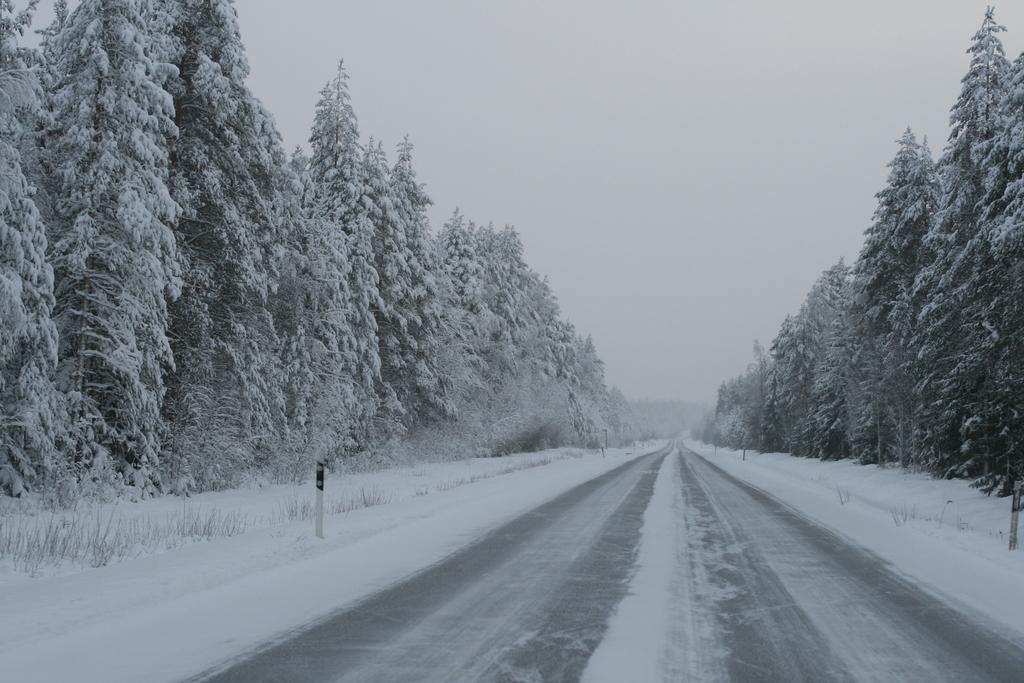What type of weather is depicted in the image? There is snow in the image, indicating cold weather. What natural elements can be seen in the image? There are trees in the image. What is visible in the background of the image? The sky is visible in the image. What time of day is the company meeting taking place in the image? There is no company meeting present in the image, as it only depicts snow, trees, and the sky. 